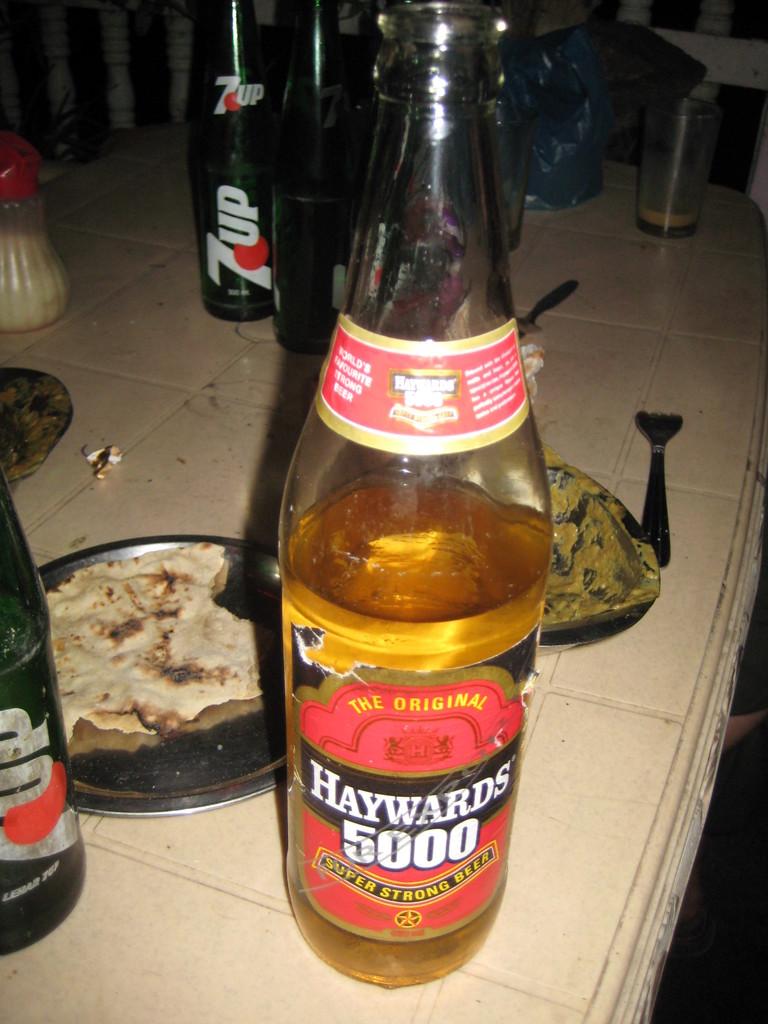Does the manufacturer of haywards 5000 beer consider it strong or super strong?
Your answer should be compact. Super strong. Is this the original?
Provide a succinct answer. Yes. 